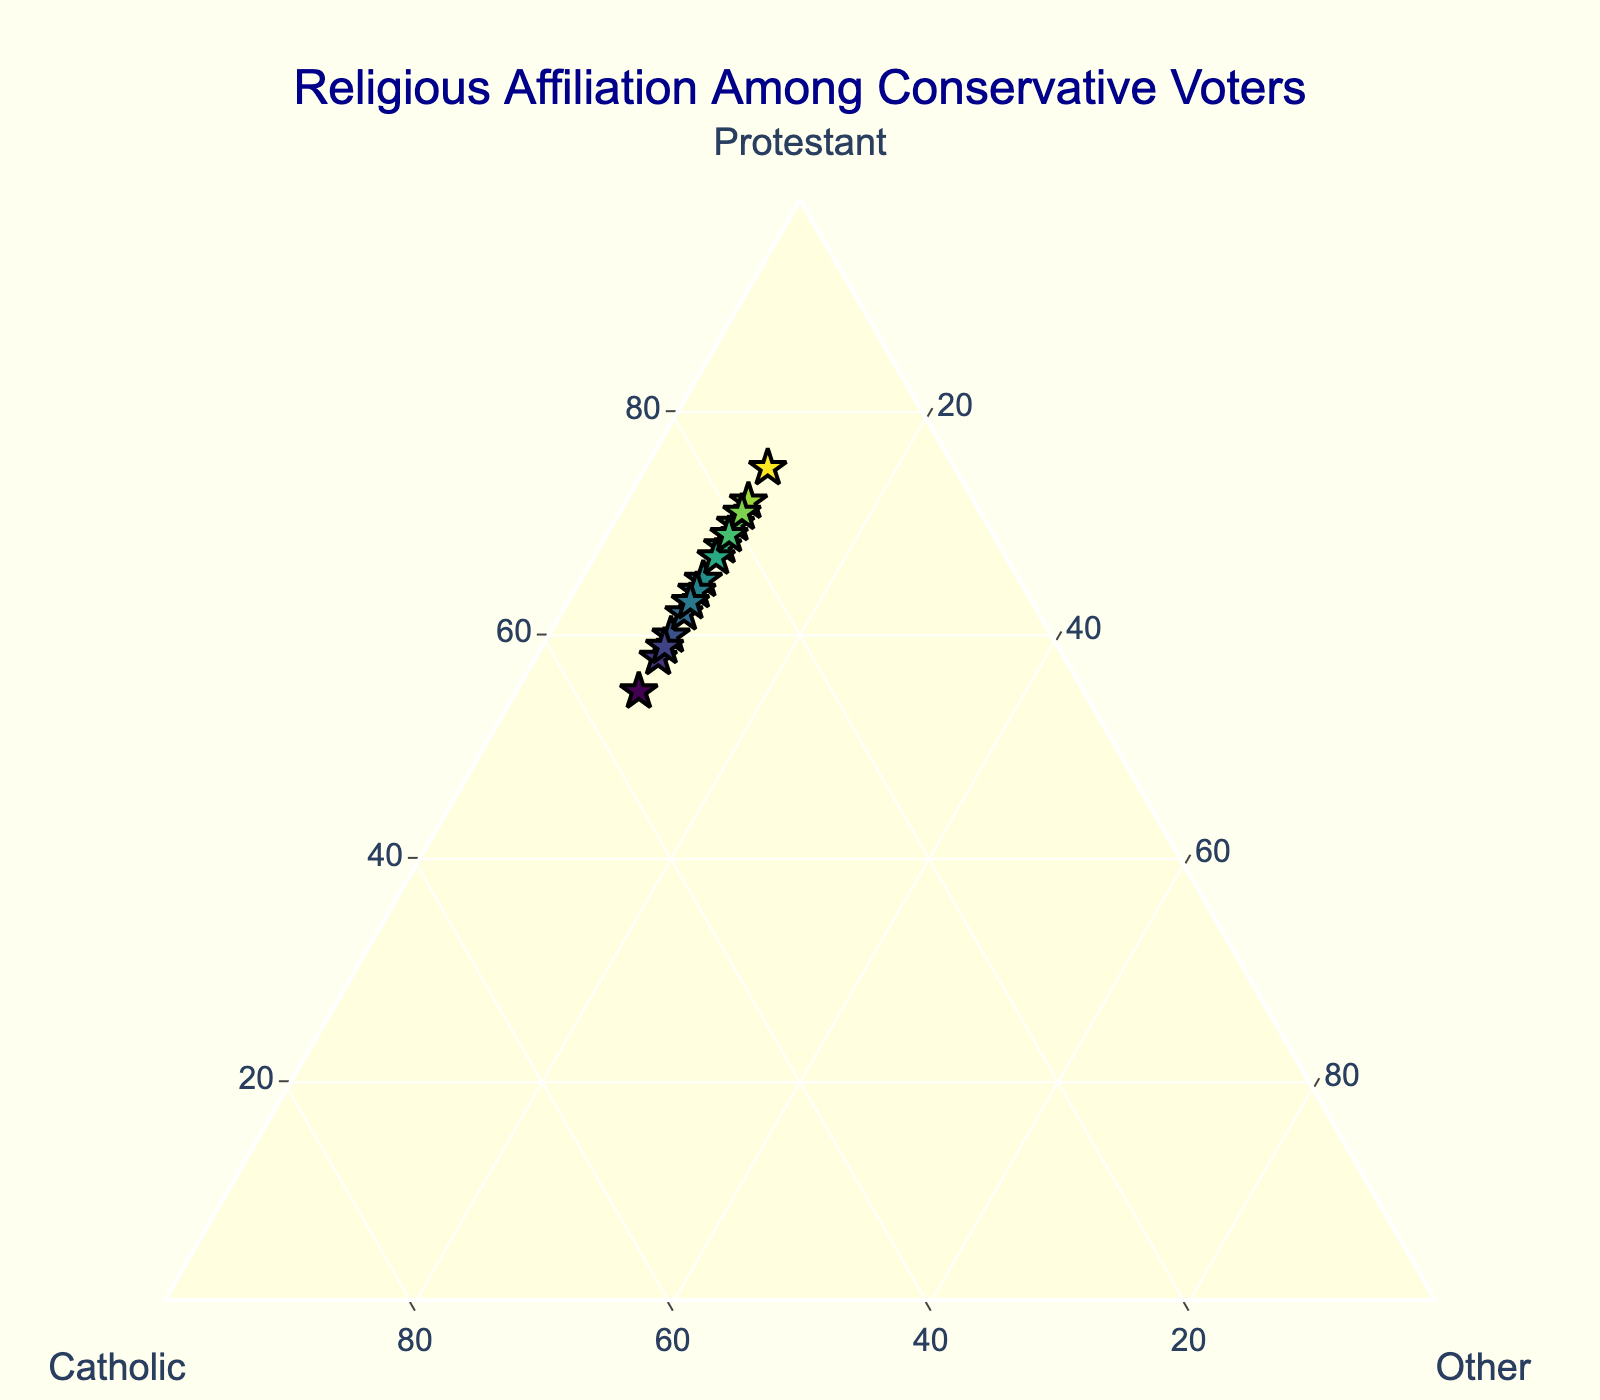What is the title of the figure? The title is positioned at the top center of the figure and can be easily read.
Answer: Religious Affiliation Among Conservative Voters What are the three religious affiliations represented in the ternary plot? Each axis of the ternary plot is labeled with one of the religious affiliations.
Answer: Protestant, Catholic, Other What is the background color of the plot? The background color of the plot is specified in the layout section of the figure configuration.
Answer: Light yellow How many data points are in the plot? By counting the number of markers in the ternary plot, you can determine the number of data points.
Answer: 15 What is the range of Protestant percentages in the data points? Observing the 'Protestant' axis, the percentages range from the smallest to the largest values displayed.
Answer: 55% to 75% What is the average percentage of Catholics among the data points? Add up all the percentages of Catholics from the data points and divide by the number of data points (sum: 396, count: 15).
Answer: 26.4% Which data point has the highest percentage of Protestants? The data point with Protestant percentage of 75% is the highest, noted on the legend.
Answer: The one with 75% Protestant What percentage of Protestants does the data point with 32% Catholics have? Refer to the data point where the Catholic percentage is 32%, check the Protestant percentage listed for it.
Answer: 58% Are there any data points where the percentage of 'Other' is greater than 10%? Check the 'Other' axis for all points to see if any are above 10%.
Answer: No 